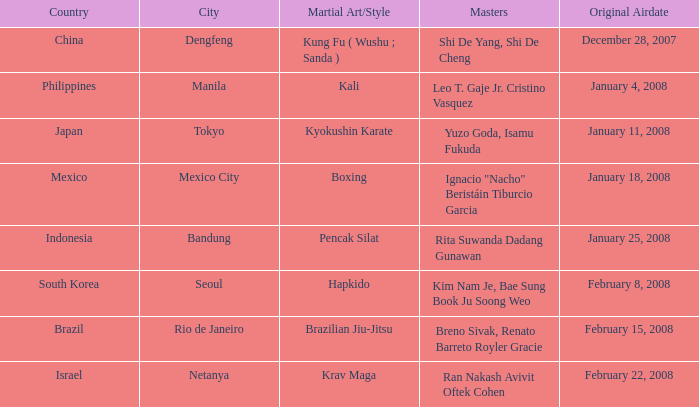When did the episode featuring a master using Brazilian jiu-jitsu air? February 15, 2008. 